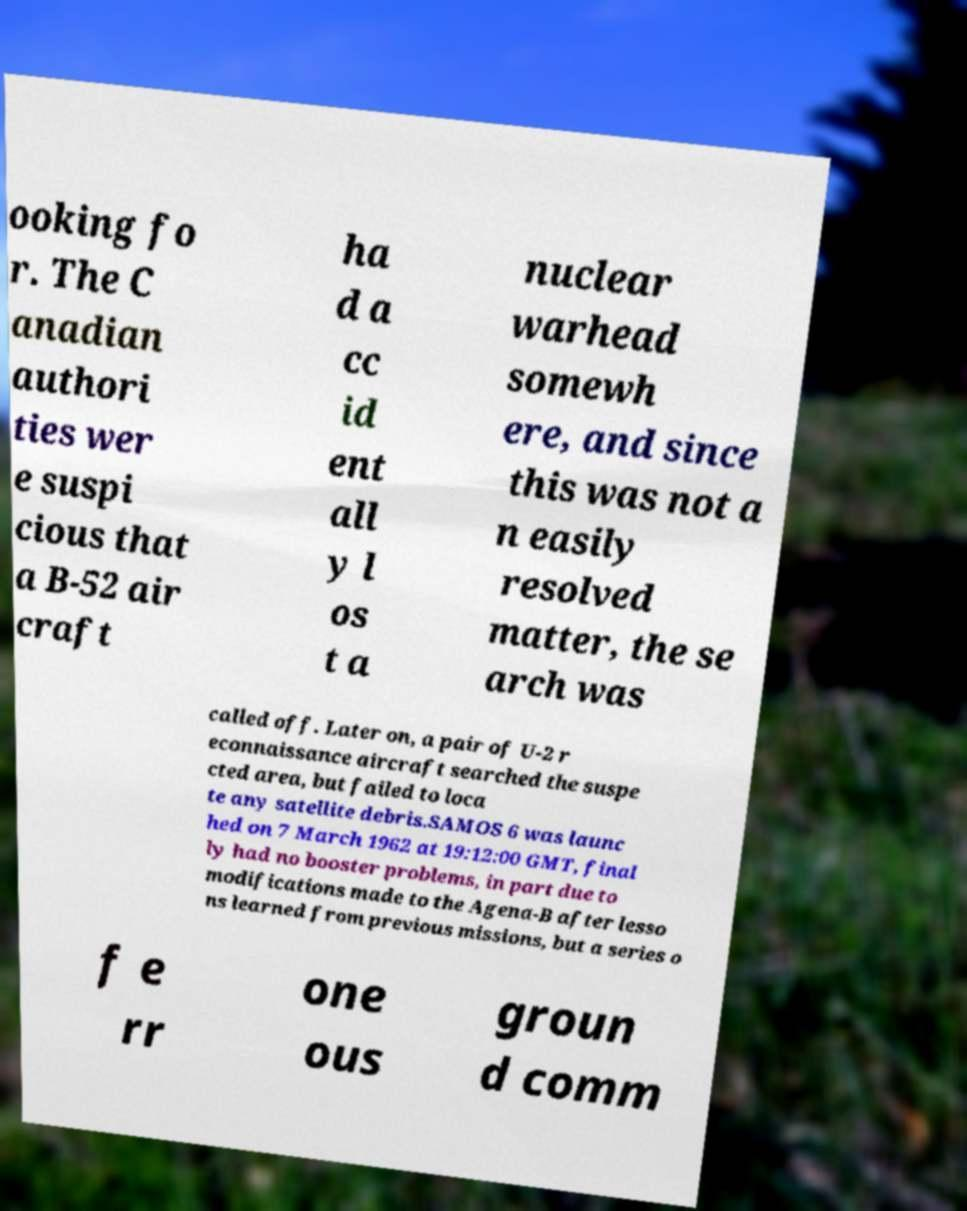There's text embedded in this image that I need extracted. Can you transcribe it verbatim? ooking fo r. The C anadian authori ties wer e suspi cious that a B-52 air craft ha d a cc id ent all y l os t a nuclear warhead somewh ere, and since this was not a n easily resolved matter, the se arch was called off. Later on, a pair of U-2 r econnaissance aircraft searched the suspe cted area, but failed to loca te any satellite debris.SAMOS 6 was launc hed on 7 March 1962 at 19:12:00 GMT, final ly had no booster problems, in part due to modifications made to the Agena-B after lesso ns learned from previous missions, but a series o f e rr one ous groun d comm 